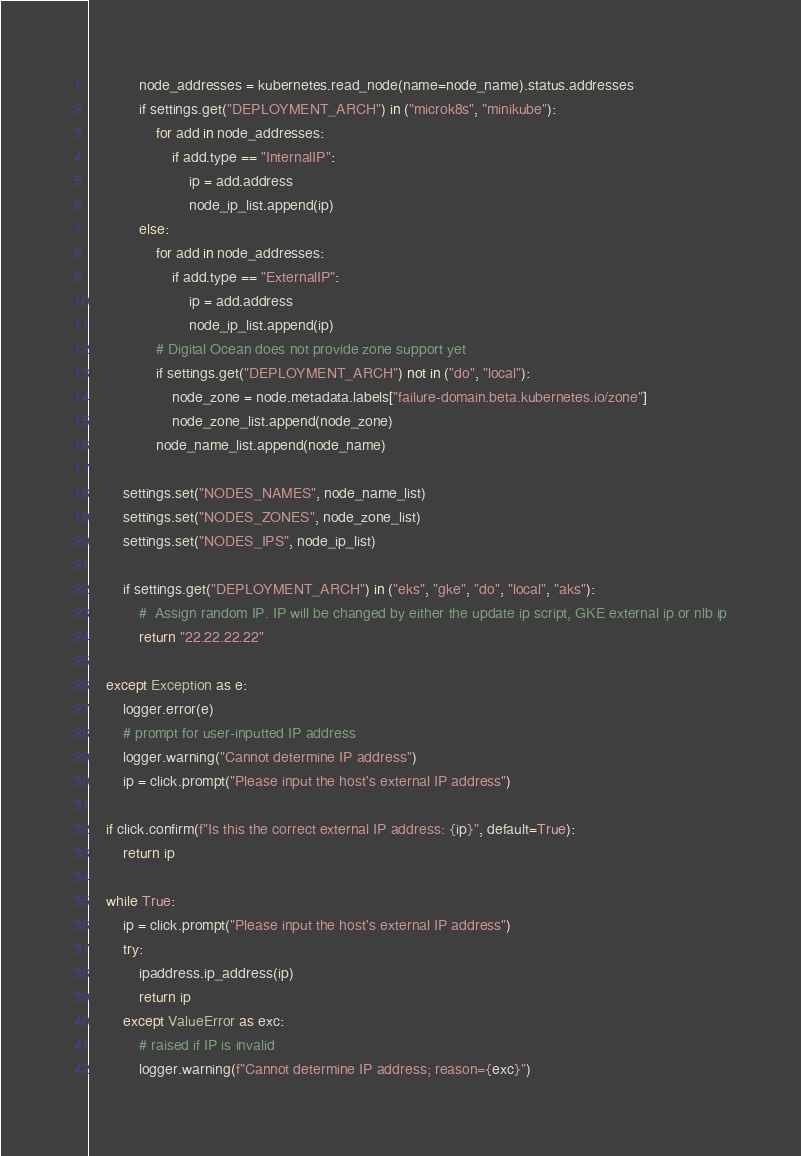Convert code to text. <code><loc_0><loc_0><loc_500><loc_500><_Python_>            node_addresses = kubernetes.read_node(name=node_name).status.addresses
            if settings.get("DEPLOYMENT_ARCH") in ("microk8s", "minikube"):
                for add in node_addresses:
                    if add.type == "InternalIP":
                        ip = add.address
                        node_ip_list.append(ip)
            else:
                for add in node_addresses:
                    if add.type == "ExternalIP":
                        ip = add.address
                        node_ip_list.append(ip)
                # Digital Ocean does not provide zone support yet
                if settings.get("DEPLOYMENT_ARCH") not in ("do", "local"):
                    node_zone = node.metadata.labels["failure-domain.beta.kubernetes.io/zone"]
                    node_zone_list.append(node_zone)
                node_name_list.append(node_name)

        settings.set("NODES_NAMES", node_name_list)
        settings.set("NODES_ZONES", node_zone_list)
        settings.set("NODES_IPS", node_ip_list)

        if settings.get("DEPLOYMENT_ARCH") in ("eks", "gke", "do", "local", "aks"):
            #  Assign random IP. IP will be changed by either the update ip script, GKE external ip or nlb ip
            return "22.22.22.22"

    except Exception as e:
        logger.error(e)
        # prompt for user-inputted IP address
        logger.warning("Cannot determine IP address")
        ip = click.prompt("Please input the host's external IP address")

    if click.confirm(f"Is this the correct external IP address: {ip}", default=True):
        return ip

    while True:
        ip = click.prompt("Please input the host's external IP address")
        try:
            ipaddress.ip_address(ip)
            return ip
        except ValueError as exc:
            # raised if IP is invalid
            logger.warning(f"Cannot determine IP address; reason={exc}")
</code> 